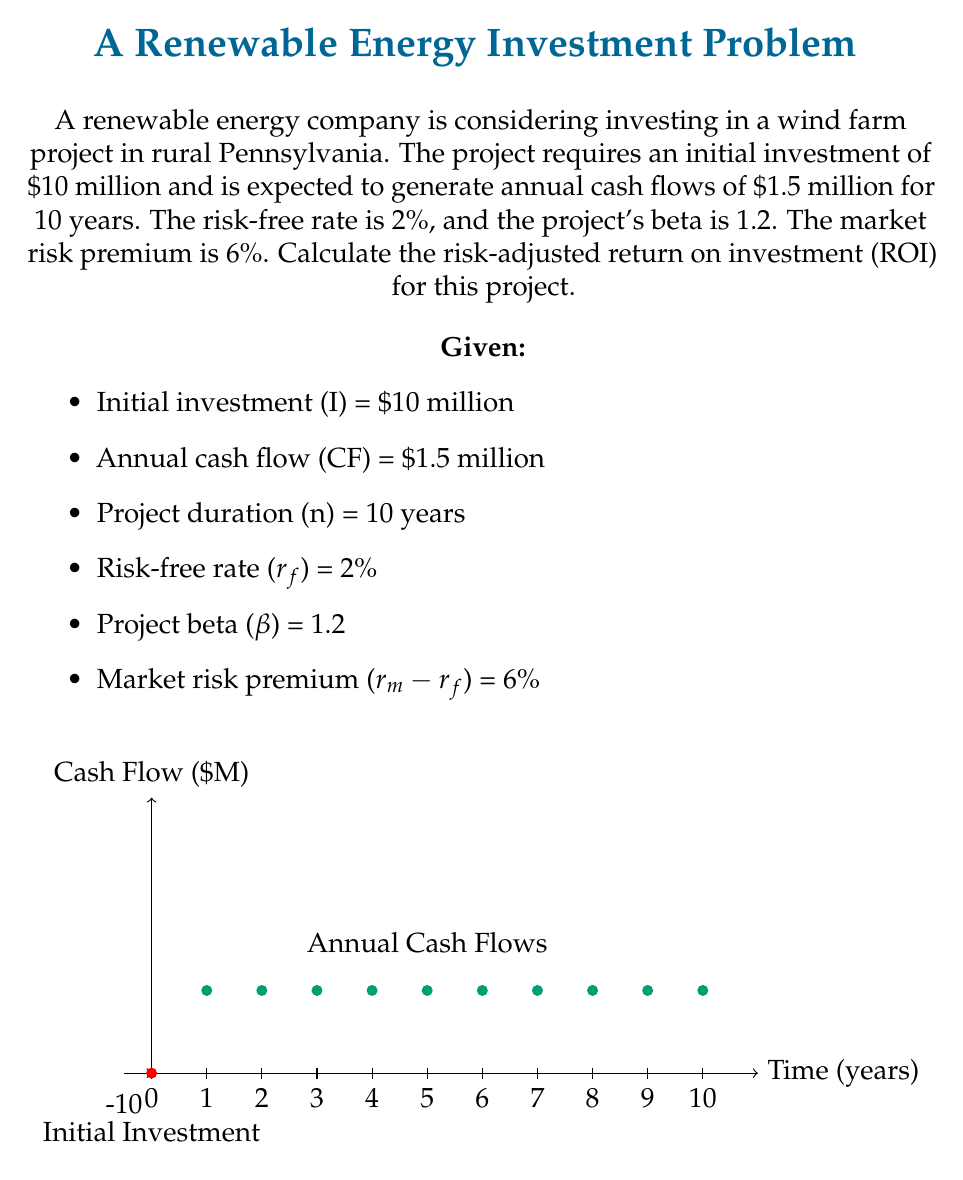What is the answer to this math problem? To calculate the risk-adjusted ROI, we'll follow these steps:

1. Calculate the required rate of return using the Capital Asset Pricing Model (CAPM):
   $$ r = r_f + \beta(r_m - r_f) $$
   $$ r = 0.02 + 1.2(0.06) = 0.092 = 9.2\% $$

2. Calculate the present value of future cash flows:
   $$ PV_{CF} = CF \times \frac{1 - (1+r)^{-n}}{r} $$
   $$ PV_{CF} = 1.5 \times \frac{1 - (1.092)^{-10}}{0.092} = 9.57 \text{ million} $$

3. Calculate the Net Present Value (NPV):
   $$ NPV = PV_{CF} - I $$
   $$ NPV = 9.57 - 10 = -0.43 \text{ million} $$

4. Calculate the Profitability Index (PI):
   $$ PI = \frac{PV_{CF}}{I} $$
   $$ PI = \frac{9.57}{10} = 0.957 $$

5. Calculate the risk-adjusted ROI:
   $$ ROI = (PI - 1) \times 100\% $$
   $$ ROI = (0.957 - 1) \times 100\% = -4.3\% $$

The negative ROI indicates that the project is not profitable given the risk-adjusted required rate of return.
Answer: -4.3% 